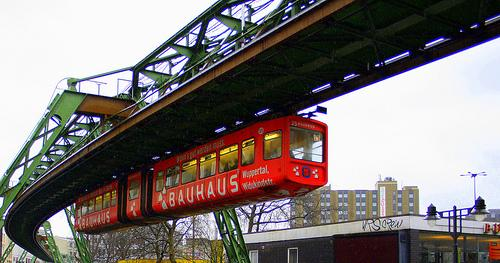Mention a unique feature of the main object in the image and its surroundings. The red train under the bridge has white writing on it and is attached to two other red train cars. Provide a concise explanation of the central focus of the image and what is happening. A hanging red train and two red train cars are moving along tracks under a bridge. Enumerate three visible features or actions taking place in the image. Red train under a bridge, white clouds in blue sky, graffiti on building facade. Write a single sentence describing the primary focus of the image and its context. A red train with two additional red cars is traveling under a bridge on an elevated track system. Express the main idea of the image in a simple and clear sentence. A triple-section red train is passing under a bridge on an elevated track. Describe the main object's appearance and its action in the image. The red train with white writing is moving under a bridge, attached to two other red train cars. Provide a brief description of the primary object in the image and its activity. A red train is traveling under a bridge, accompanied by two other red train cars. In one sentence, describe the key elements of the scene depicted in the image. A red train with white lettering travels under a bridge, while two other red train cars follow closely behind. Provide a one-sentence explanation of the main subject of the image and its situation. A red train, along with two other red train cars, travels under a bridge on raised tracks. In one statement, describe the major subject and its significant features in the image. The hanging red train with white lettering and two accompanying red train cars travel under a bridge. 